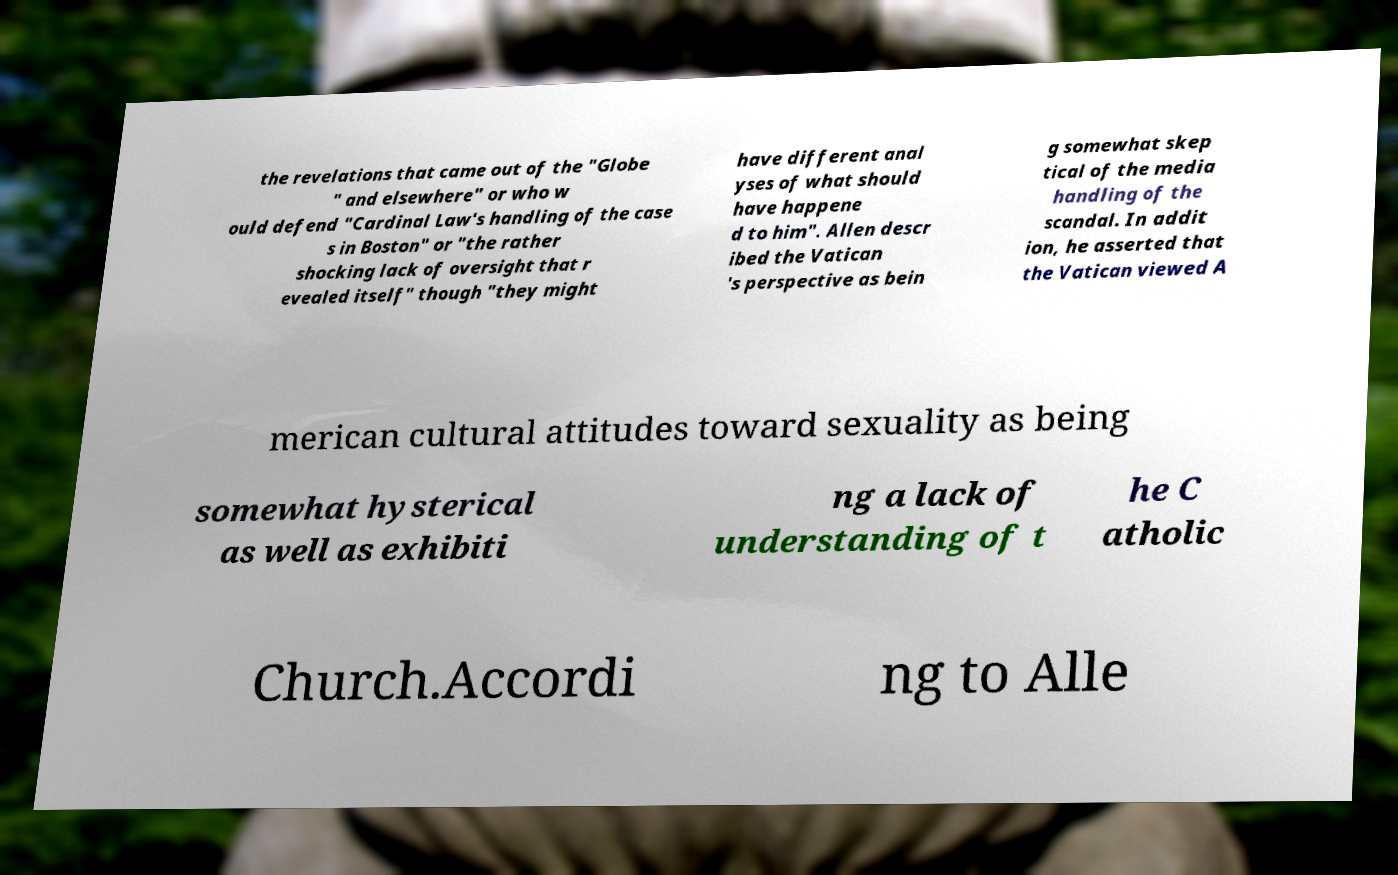What messages or text are displayed in this image? I need them in a readable, typed format. the revelations that came out of the "Globe " and elsewhere" or who w ould defend "Cardinal Law's handling of the case s in Boston" or "the rather shocking lack of oversight that r evealed itself" though "they might have different anal yses of what should have happene d to him". Allen descr ibed the Vatican 's perspective as bein g somewhat skep tical of the media handling of the scandal. In addit ion, he asserted that the Vatican viewed A merican cultural attitudes toward sexuality as being somewhat hysterical as well as exhibiti ng a lack of understanding of t he C atholic Church.Accordi ng to Alle 